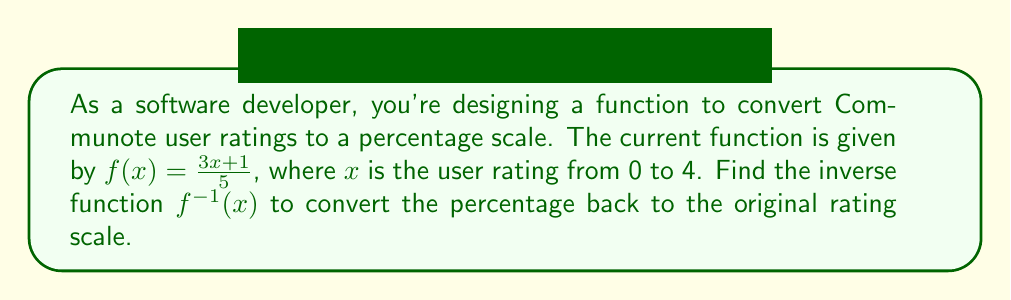Show me your answer to this math problem. To find the inverse function, we'll follow these steps:

1. Replace $f(x)$ with $y$:
   $y = \frac{3x + 1}{5}$

2. Swap $x$ and $y$:
   $x = \frac{3y + 1}{5}$

3. Solve for $y$:
   $5x = 3y + 1$
   $5x - 1 = 3y$
   $\frac{5x - 1}{3} = y$

4. Replace $y$ with $f^{-1}(x)$:
   $f^{-1}(x) = \frac{5x - 1}{3}$

This inverse function will convert the percentage back to the original rating scale.
Answer: $f^{-1}(x) = \frac{5x - 1}{3}$ 